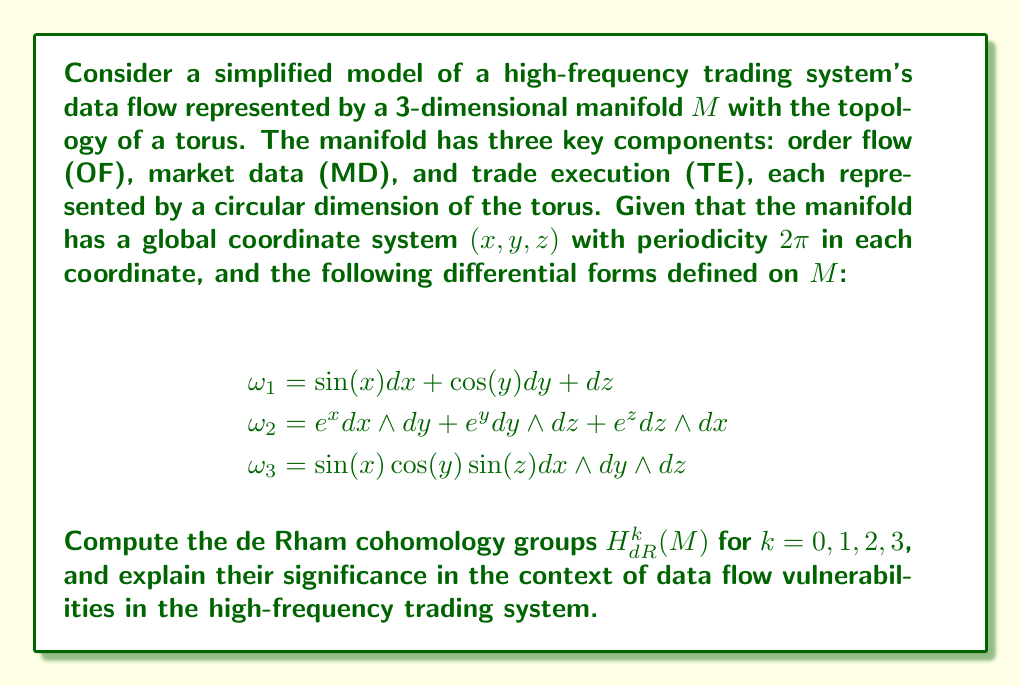Can you solve this math problem? To compute the de Rham cohomology groups of the manifold $M$, we need to analyze the closed and exact forms in each dimension. Let's go through this step-by-step:

1) For $H^0_{dR}(M)$:
   This group consists of locally constant functions on $M$. Since $M$ is connected (being a torus), $H^0_{dR}(M) \cong \mathbb{R}$.

2) For $H^1_{dR}(M)$:
   We need to find closed 1-forms that are not exact. The basis for 1-forms on $M$ is $\{dx, dy, dz\}$.
   All exact 1-forms are of the form $df = \frac{\partial f}{\partial x}dx + \frac{\partial f}{\partial y}dy + \frac{\partial f}{\partial z}dz$ for some function $f$.
   The closed forms that are not exact are $dx$, $dy$, and $dz$.
   Therefore, $H^1_{dR}(M) \cong \mathbb{R}^3$.

3) For $H^2_{dR}(M)$:
   The basis for 2-forms on $M$ is $\{dx \wedge dy, dy \wedge dz, dz \wedge dx\}$.
   Closed 2-forms that are not exact are $dx \wedge dy$, $dy \wedge dz$, and $dz \wedge dx$.
   Thus, $H^2_{dR}(M) \cong \mathbb{R}^3$.

4) For $H^3_{dR}(M)$:
   The only 3-form on $M$ is $dx \wedge dy \wedge dz$, which is closed but not exact.
   Therefore, $H^3_{dR}(M) \cong \mathbb{R}$.

Significance in the context of data flow vulnerabilities:

1) $H^0_{dR}(M) \cong \mathbb{R}$ indicates that the system has one connected component, suggesting a single integrated trading system.

2) $H^1_{dR}(M) \cong \mathbb{R}^3$ represents three independent circular flows in the system: order flow (OF), market data (MD), and trade execution (TE). Each of these could be a potential point of vulnerability if compromised.

3) $H^2_{dR}(M) \cong \mathbb{R}^3$ suggests three independent surface-like structures in the data flow. These could represent interfaces between pairs of components (OF-MD, MD-TE, TE-OF), which are potential areas for data interception or manipulation.

4) $H^3_{dR}(M) \cong \mathbb{R}$ indicates a single global volume form, representing the overall integrity of the system. A breach affecting this could compromise the entire trading system.

The given differential forms $\omega_1$, $\omega_2$, and $\omega_3$ represent specific data flows in the system. Their analysis could reveal more detailed vulnerabilities:

- $\omega_1$ shows coupling between the three components, indicating that a disruption in one could affect the others.
- $\omega_2$ represents pairwise interactions, which could be targets for man-in-the-middle attacks.
- $\omega_3$ shows a global interaction of all components, possibly representing the core trading algorithm, which would be a critical point of security.
Answer: The de Rham cohomology groups of the manifold $M$ are:

$$H^0_{dR}(M) \cong \mathbb{R}$$
$$H^1_{dR}(M) \cong \mathbb{R}^3$$
$$H^2_{dR}(M) \cong \mathbb{R}^3$$
$$H^3_{dR}(M) \cong \mathbb{R}$$

These groups reveal potential vulnerabilities in the order flow, market data, and trade execution components, their interfaces, and the overall system integrity of the high-frequency trading system. 